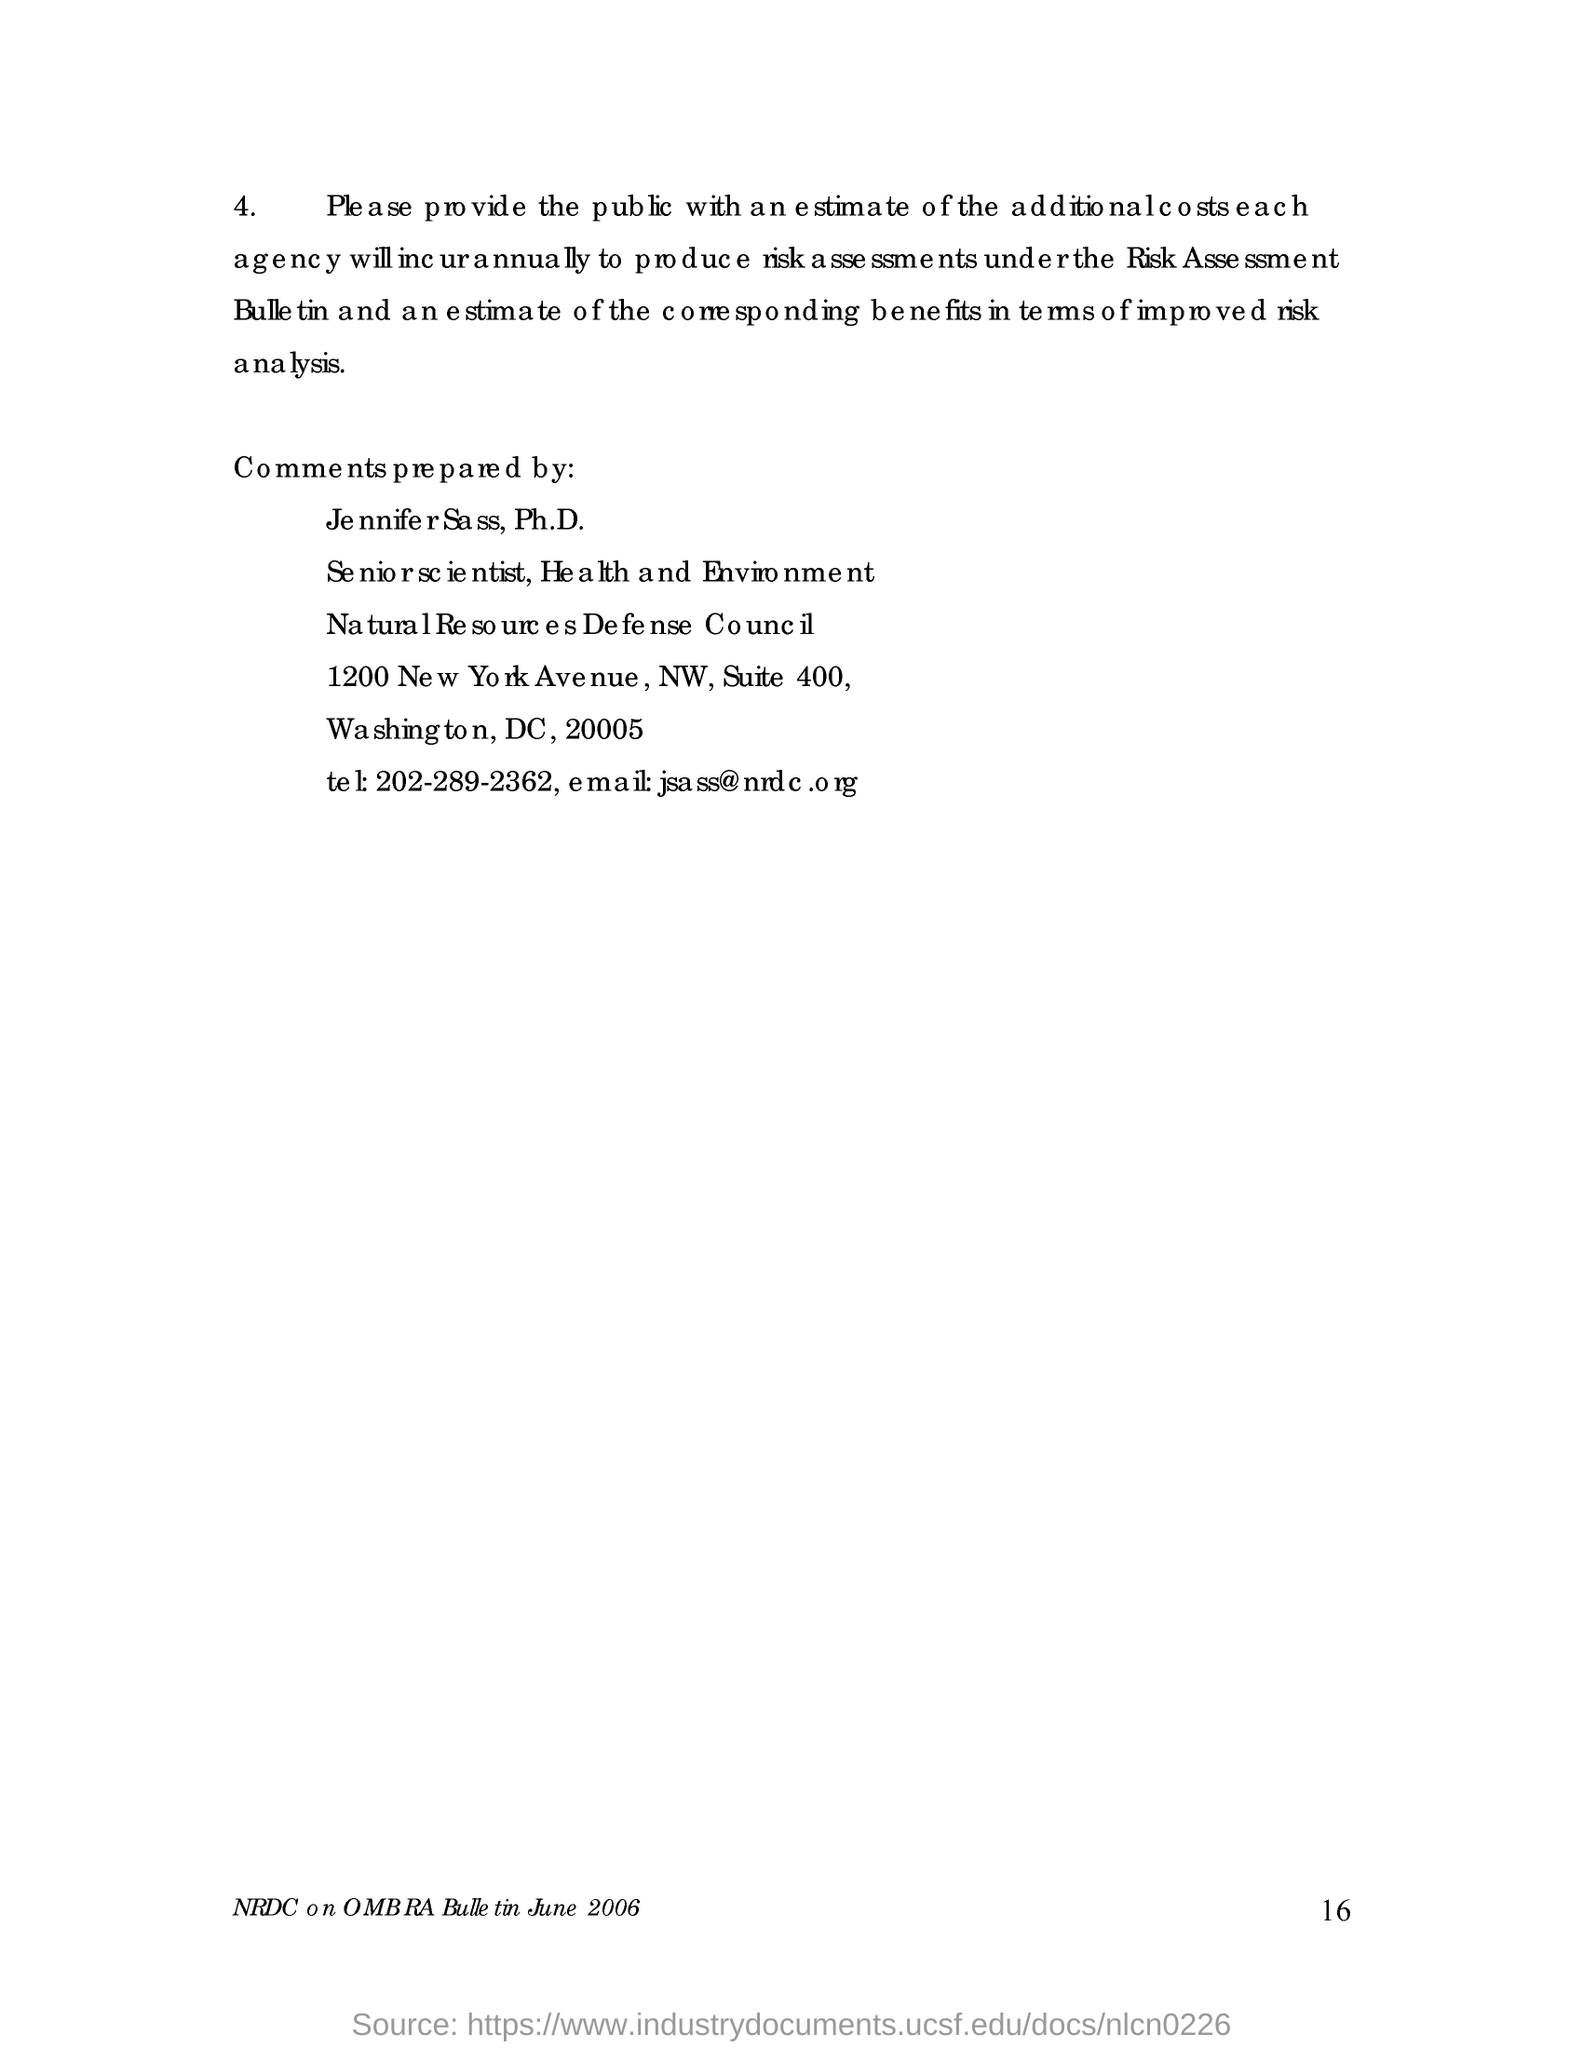What is the page no mentioned in this document?
Your answer should be compact. 16. What is the date mentioned in this document?
Give a very brief answer. June 2006. Who prepared the comments for this document?
Give a very brief answer. Je nnife r Sa ss, Ph.D. What is the name of the council?
Provide a short and direct response. Natural Resources Defense Council. 